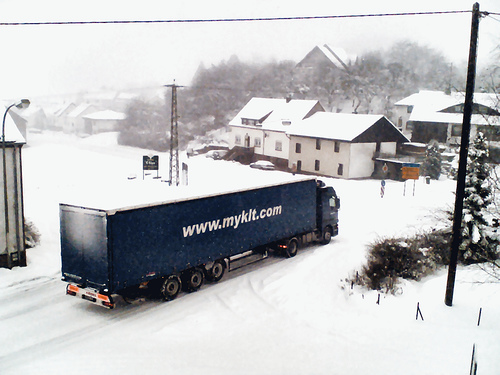Can you describe the weather conditions and how they may affect transportation? The weather appears to be snowy with reduced visibility, which can lead to slippery roads and hazardous driving conditions. Such weather necessitates cautious driving, potentially slower speeds, and could result in delays in transportation and delivery services. 